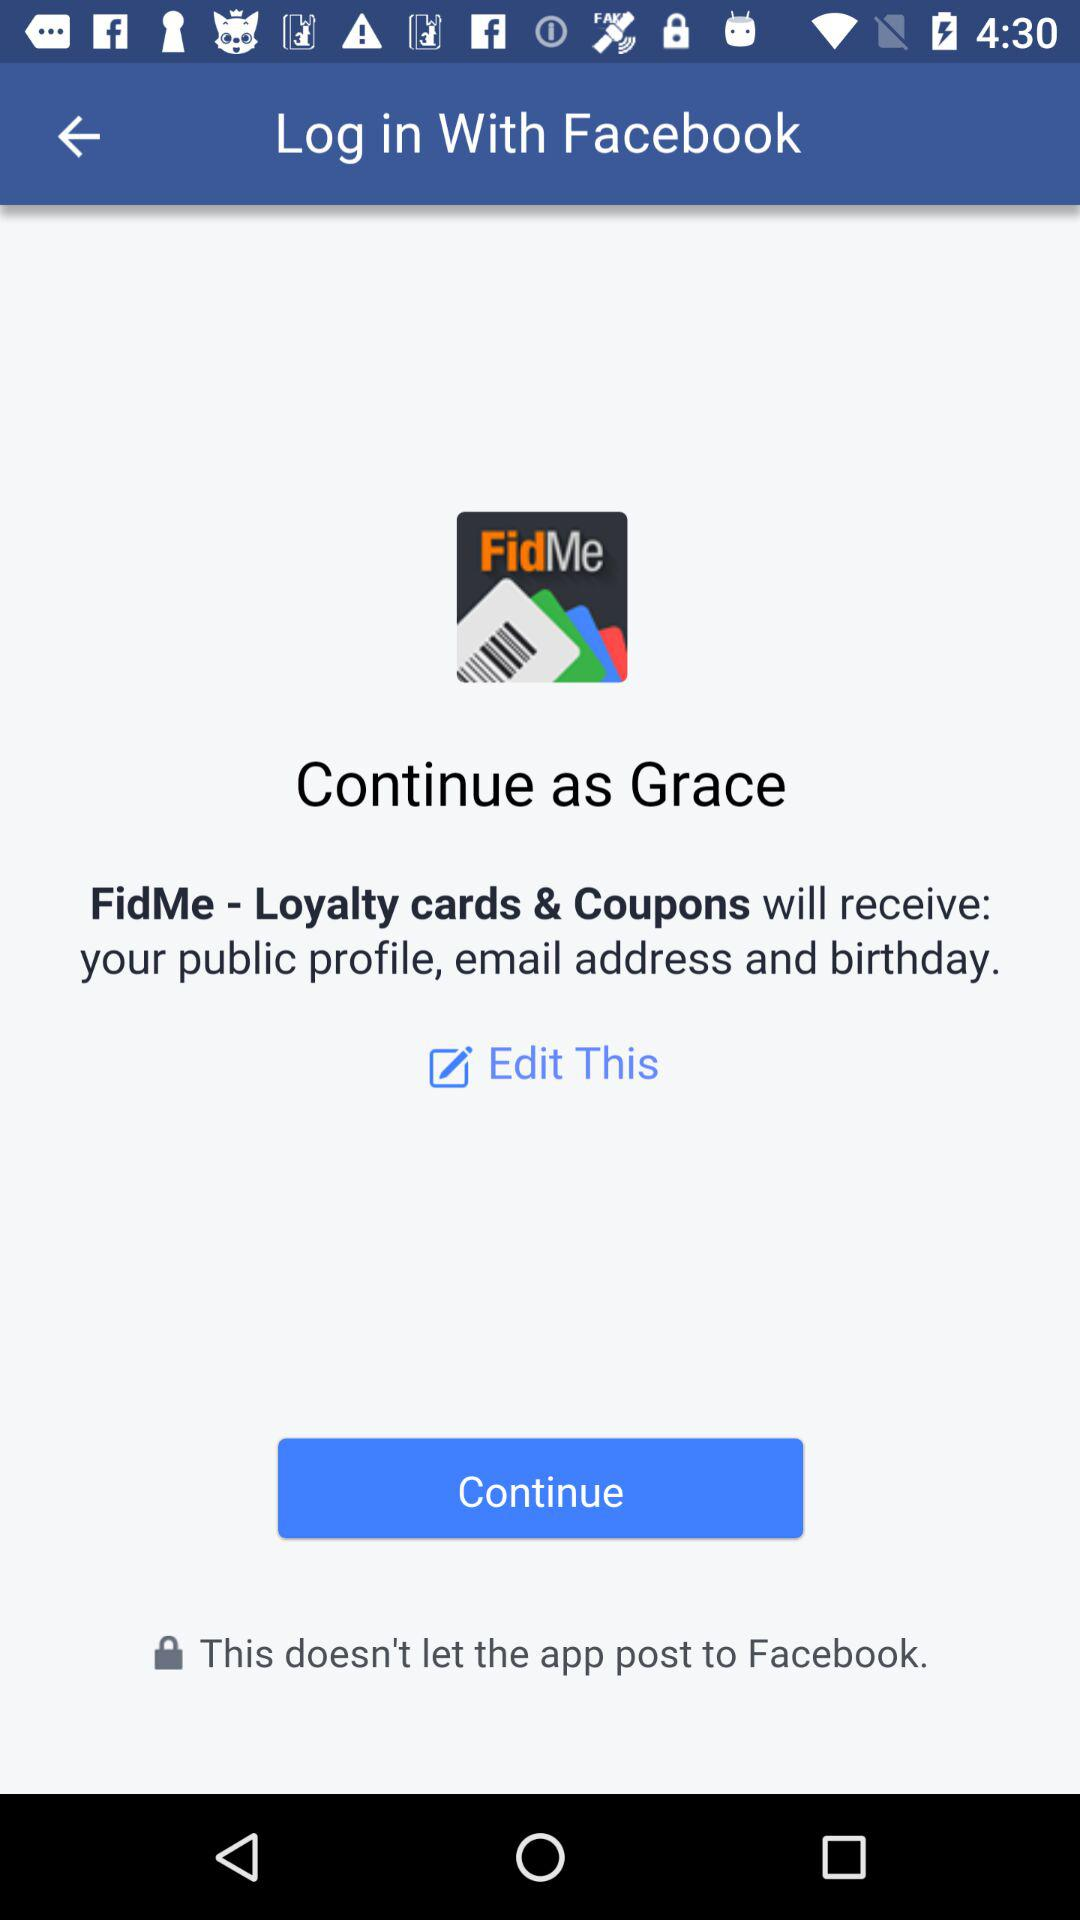What is the name? The name is Grace. 